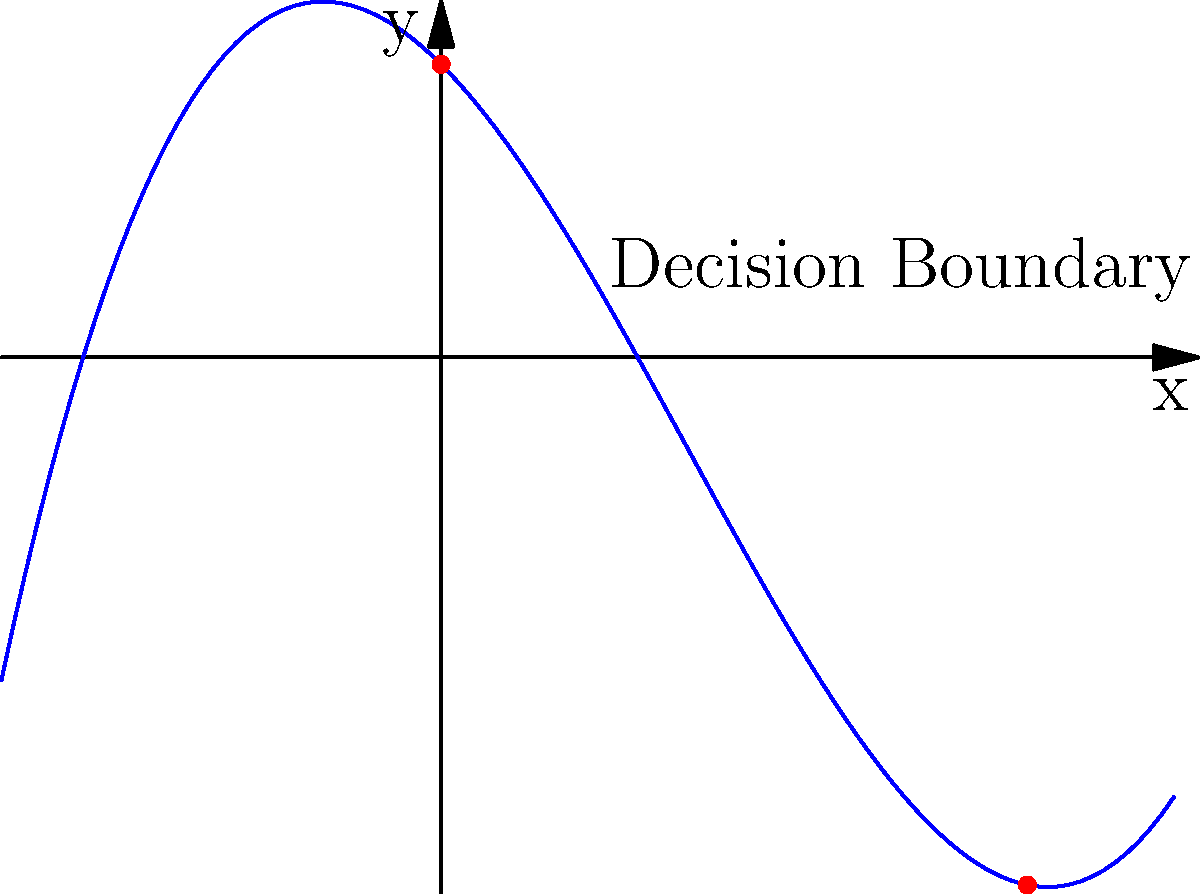Given the polynomial function $f(x) = 0.1x^3 - 0.5x^2 - x + 2$ representing an AI decision boundary in a 2D space, determine the number of decision regions created by this boundary. How might this impact the complexity of the AI model's decision-making process? To answer this question, we need to analyze the polynomial function and its graph:

1. The function $f(x) = 0.1x^3 - 0.5x^2 - x + 2$ is a cubic polynomial.

2. From the graph, we can see that the curve intersects the x-axis at two points: near x = 0 and x = 4.

3. These intersection points divide the 2D space into three regions:
   - Region 1: $x < 0$ (approximately)
   - Region 2: $0 < x < 4$ (approximately)
   - Region 3: $x > 4$

4. In the context of AI decision boundaries, each region typically represents a different classification or decision outcome.

5. Having three decision regions implies that the AI model can distinguish between three different classes or make three distinct types of decisions based on the input features represented by the x and y axes.

6. The complexity of the decision boundary (a cubic function) suggests that the AI model is capable of capturing non-linear relationships between input features.

7. This increased complexity allows for more nuanced decision-making but may also increase the risk of overfitting if not properly regularized.

8. In terms of JavaScript implementation, this would require more complex logic to determine which region a given input belongs to, potentially increasing computational cost.
Answer: 3 decision regions; increased model complexity and decision-making nuance. 